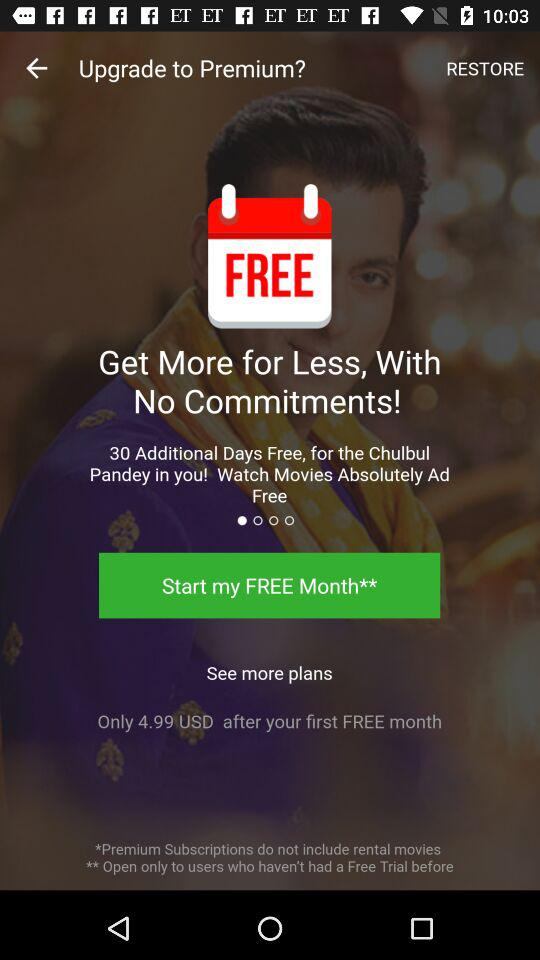How much is the monthly subscription after the free trial?
Answer the question using a single word or phrase. 4.99 USD 